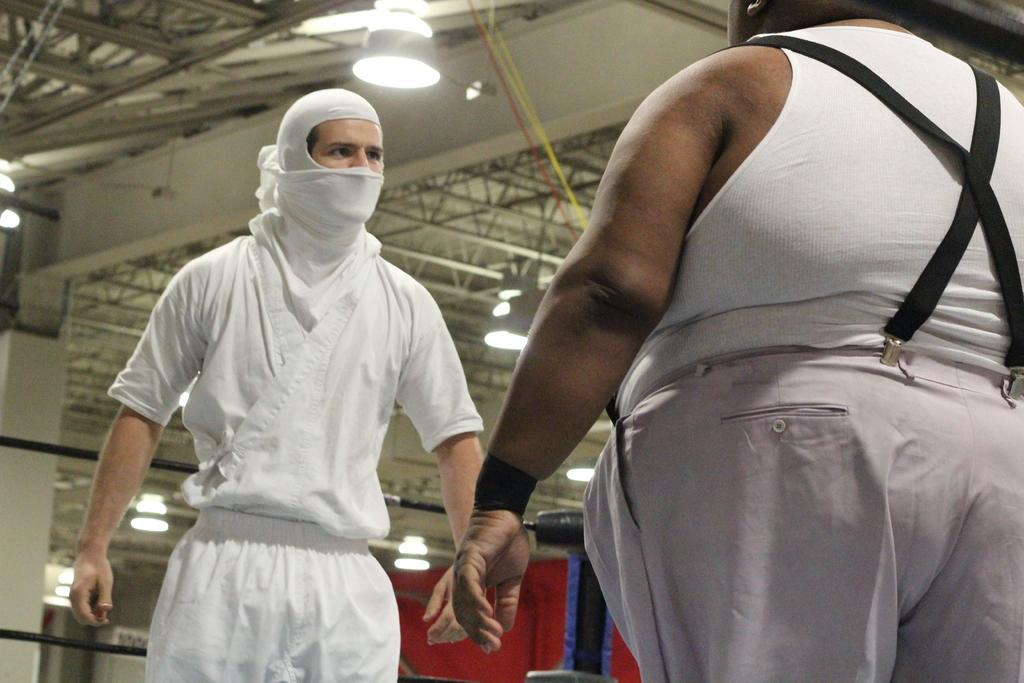How many people are in the image? There are two persons standing in the image. What is one person wearing? One person is wearing a scarf. What can be seen on the ceiling in the image? There are lights and rods on the ceiling. What color is the prominent object in the background? There is a red color thing in the background. What type of soup is being served in the image? There is no soup present in the image. What stage of development is the snail in the image? There is no snail present in the image. 